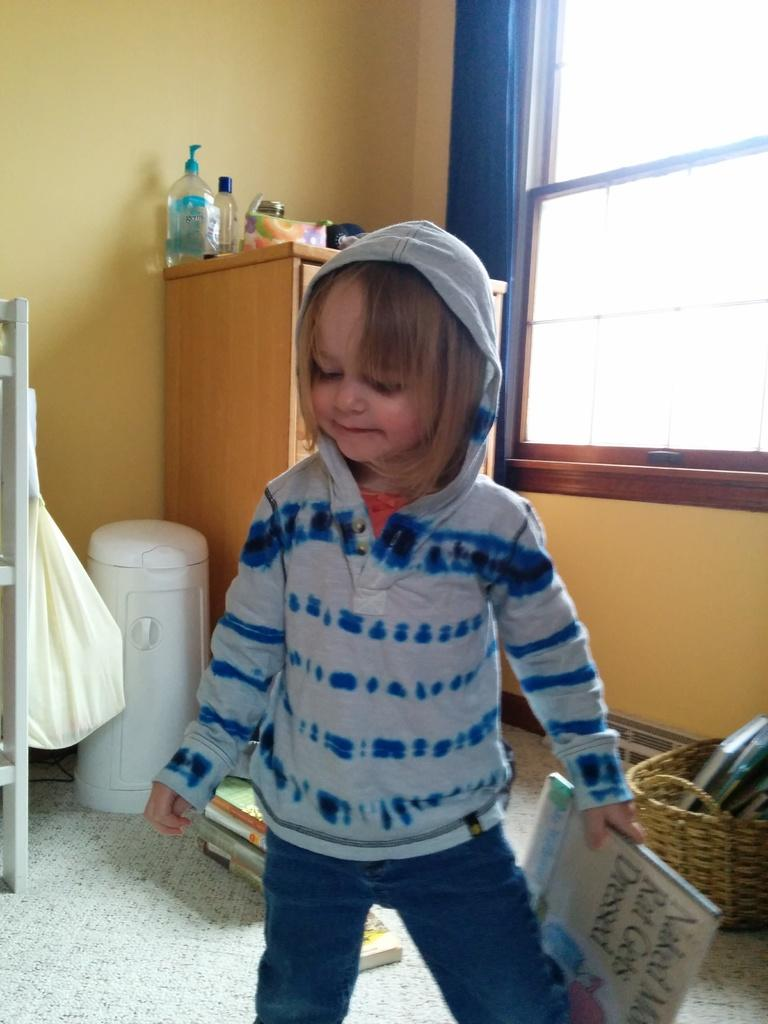What is the kid doing in the image? The kid is standing on the floor and holding a book. What can be seen in the background of the image? In the background, there is a basket, books, bottles, a packet, a cupboard, a curtain associated with a window, and a window. Can you describe the objects on the floor? The only object on the floor is the kid holding a book. Is the kid holding a rifle in the image? No, the kid is not holding a rifle in the image; they are holding a book. 